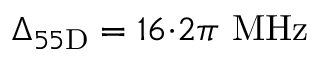<formula> <loc_0><loc_0><loc_500><loc_500>\Delta _ { 5 5 D } = 1 6 { \cdot } 2 \pi \ M H z</formula> 